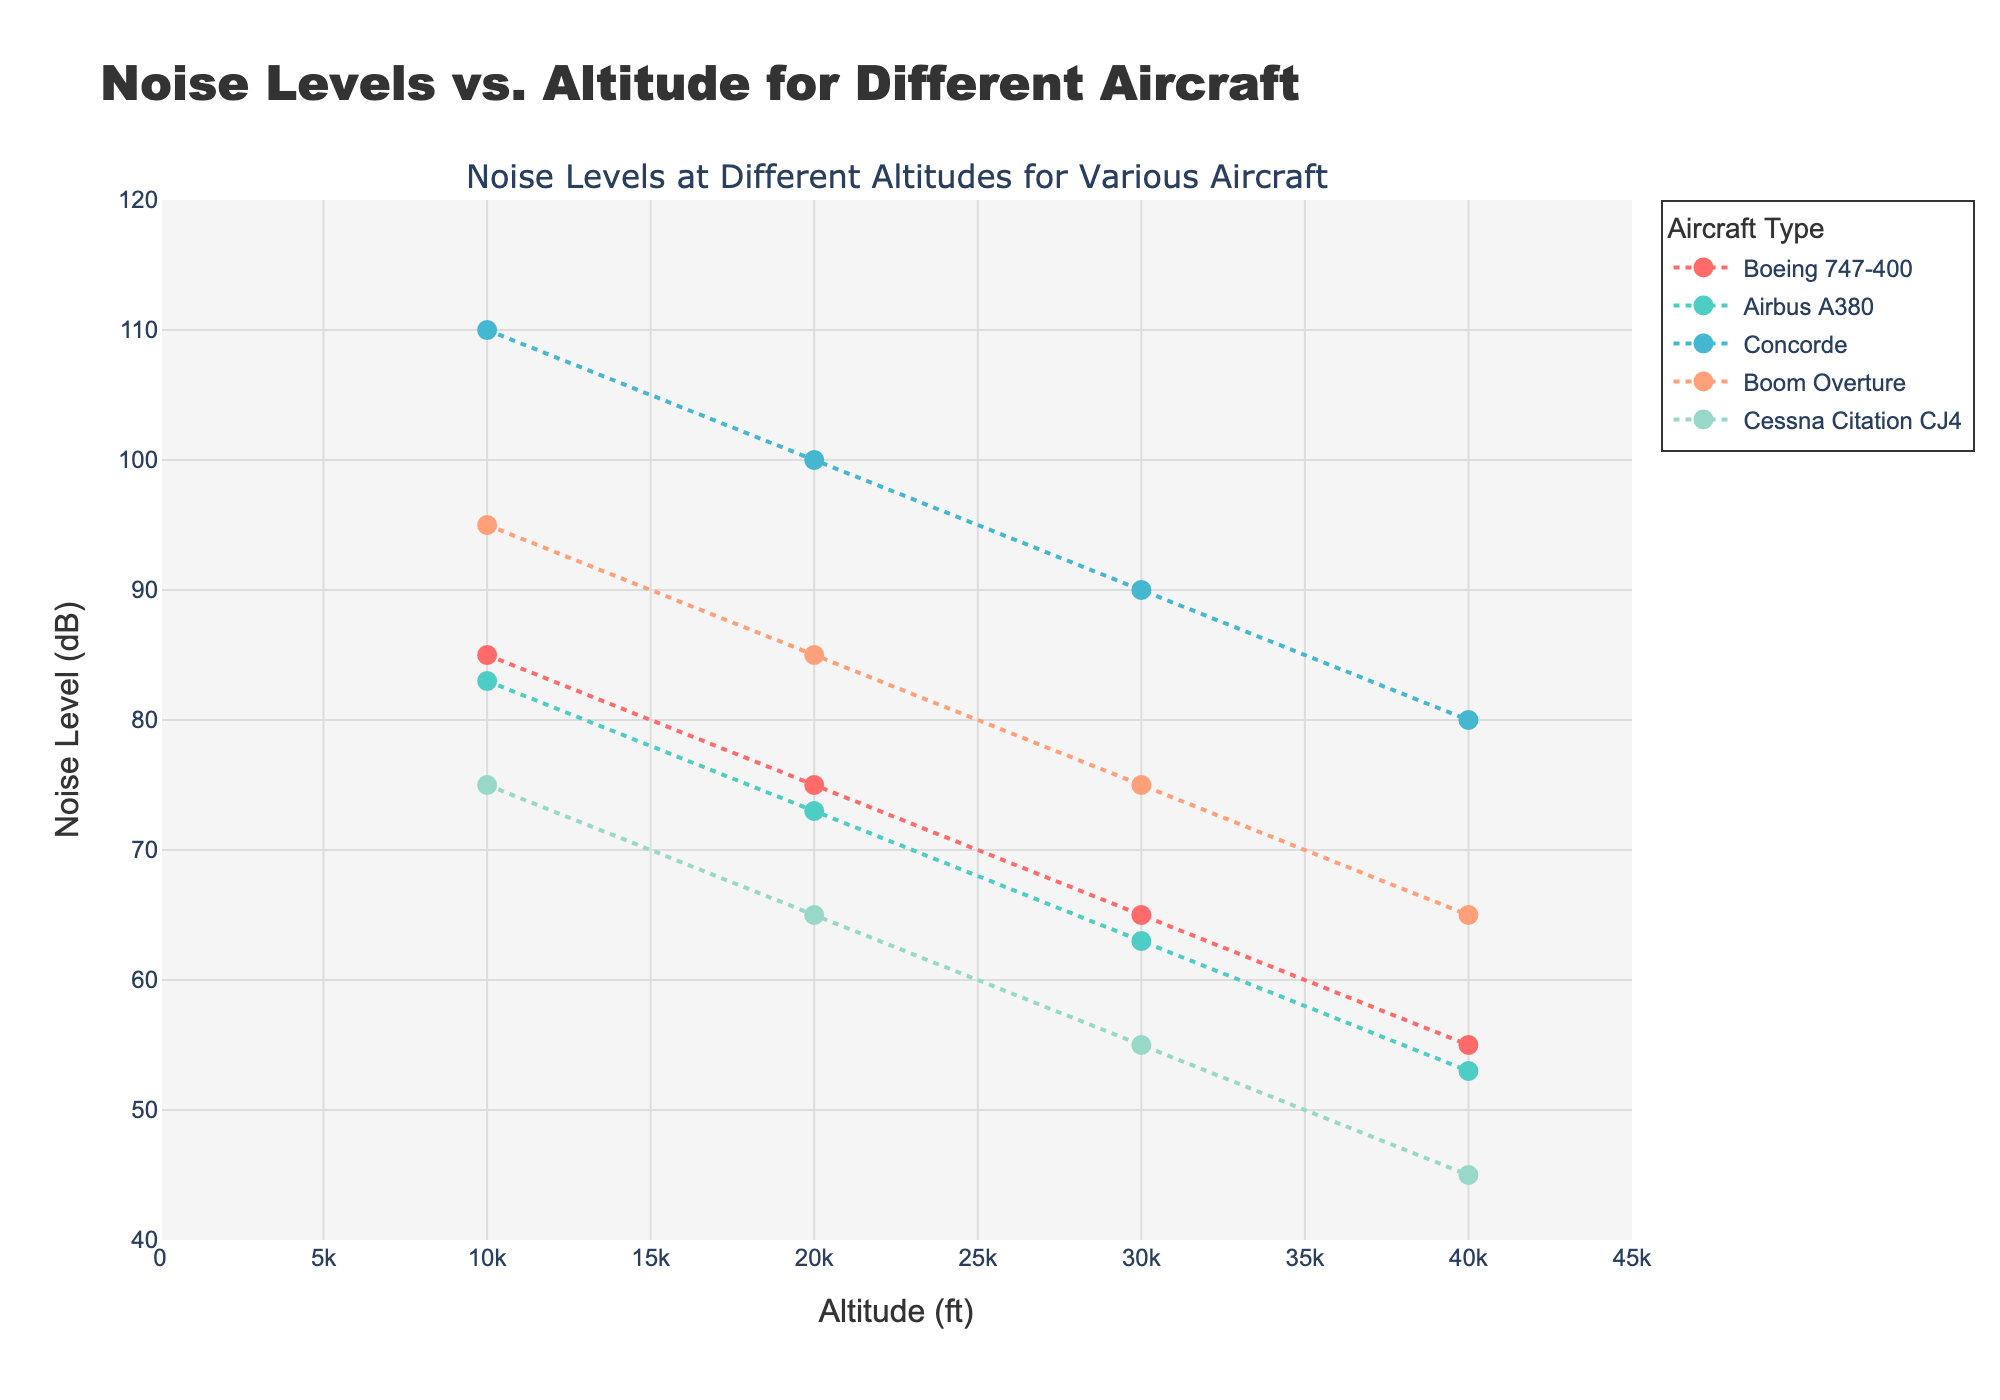What is the title of the plot? The title is usually located at the top of the plot and is used to describe what the plot is about.
Answer: Noise Levels vs. Altitude for Different Aircraft Which axis represents the altitude, and which one represents the noise level? The x-axis represents 'Altitude (ft)', while the y-axis represents 'Noise Level (dB)'. This is determined by looking at the labels along the horizontal and vertical axes.
Answer: x-axis: Altitude, y-axis: Noise Level How many aircraft types are shown in the plot? The legend to the right of the plot lists each aircraft type, and there are five distinct colors representing different aircraft types.
Answer: Five Which aircraft has the highest noise level at 10,000 ft? By looking along the x-axis at the 10,000 ft mark and tracing vertically upwards, the Concorde’s data point appears at the highest noise level.
Answer: Concorde Which aircraft exhibits the lowest noise level at 40,000 ft? By identifying the 40,000 ft mark on the x-axis and tracing vertically upwards, the Cessna Citation CJ4 has the lowest data point on the y-axis.
Answer: Cessna Citation CJ4 What is the noise reduction from 10,000 ft to 40,000 ft for the Airbus A380? The noise level for Airbus A380 at 10,000 ft is 83 dB, and at 40,000 ft it is 53 dB; the difference (83 - 53) provides the reduction.
Answer: 30 dB Is the Boom Overture louder than Boeing 747-400 at 30,000 ft? At 30,000 ft, comparing the y-values of Boom Overture (75 dB) and Boeing 747-400 (65 dB), Boom Overture's value is higher.
Answer: Yes Which aircraft shows the steepest decline in noise level as altitude increases? By visually examining the slopes of the lines or rate of decline from 10,000 ft to 40,000 ft, the Concorde shows the steepest decline.
Answer: Concorde Which two aircraft types have a similar noise level at 20,000 ft? Looking at 20,000 ft on the x-axis and comparing y-values, the Boom Overture and the Airbus A380 have similar noise levels (85 dB and 73 dB, respectively).
Answer: Boom Overture and Airbus A380 What can be inferred about the relationship between altitude and noise level for the aircraft in the plot? Observing all lines, there is a clear trend that as altitude increases, the noise levels decrease systematically for all aircraft.
Answer: Noise level decreases with increasing altitude 